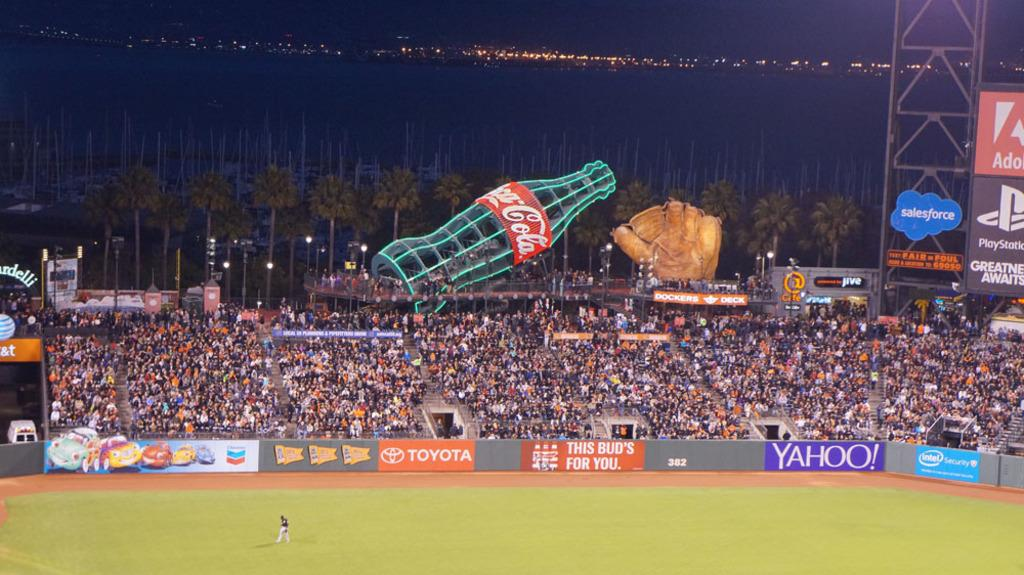<image>
Render a clear and concise summary of the photo. A giant baseball mitt and Coca-Cola bottle dot the boundary of this baseball stadium. 